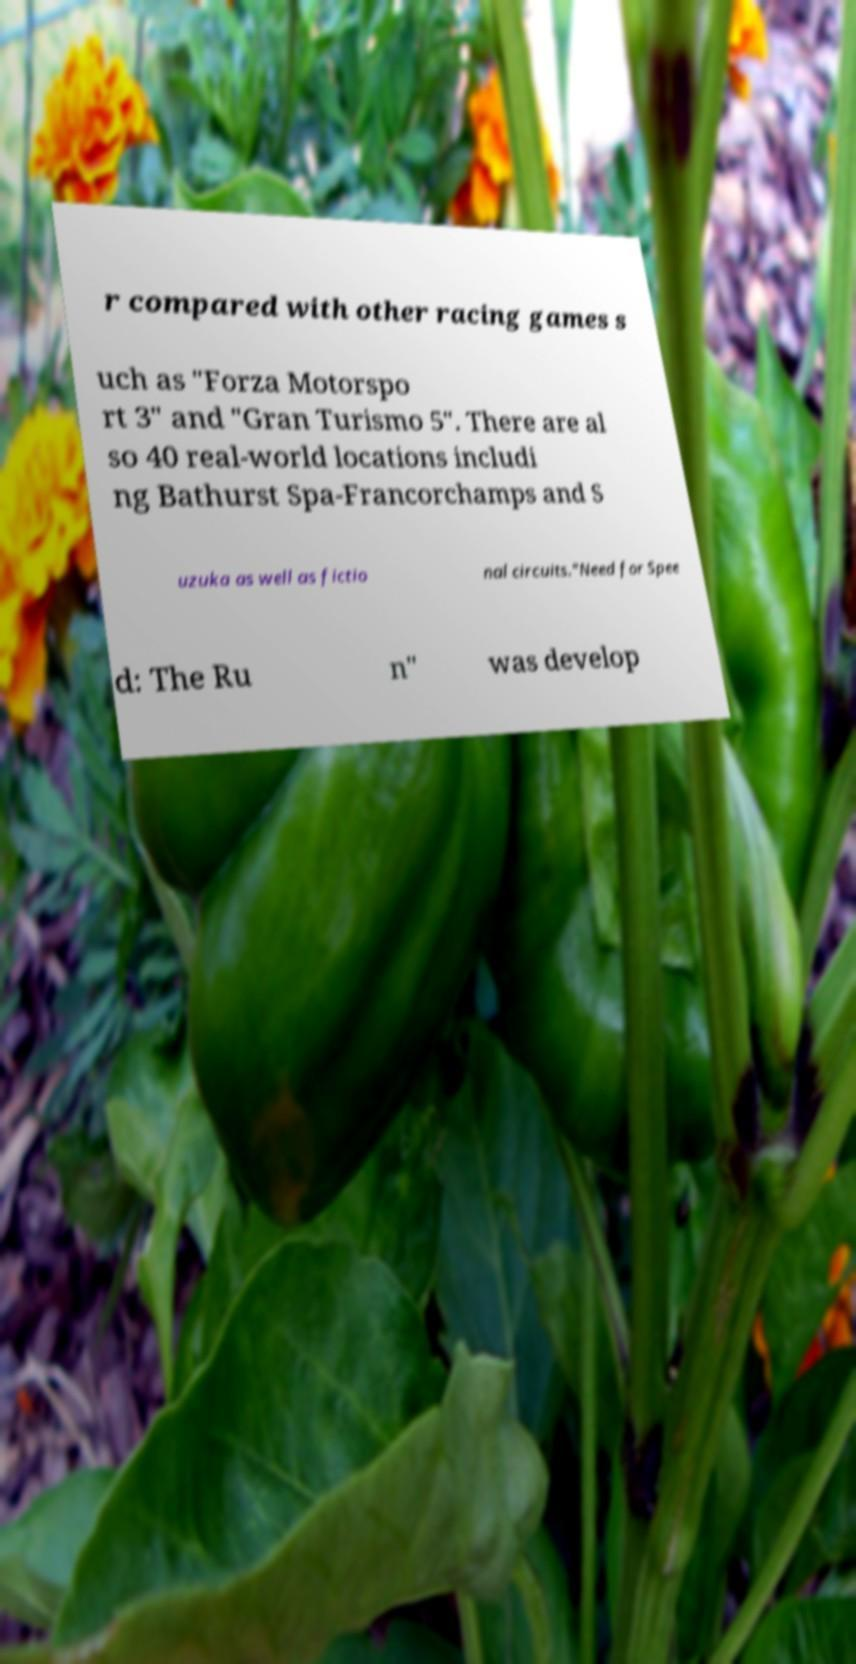Please identify and transcribe the text found in this image. r compared with other racing games s uch as "Forza Motorspo rt 3" and "Gran Turismo 5". There are al so 40 real-world locations includi ng Bathurst Spa-Francorchamps and S uzuka as well as fictio nal circuits."Need for Spee d: The Ru n" was develop 